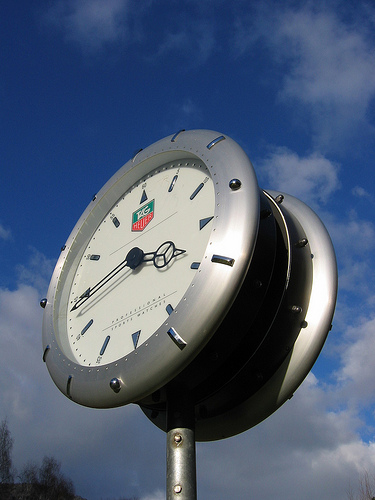<image>
Can you confirm if the clock is on the cloud? No. The clock is not positioned on the cloud. They may be near each other, but the clock is not supported by or resting on top of the cloud. 